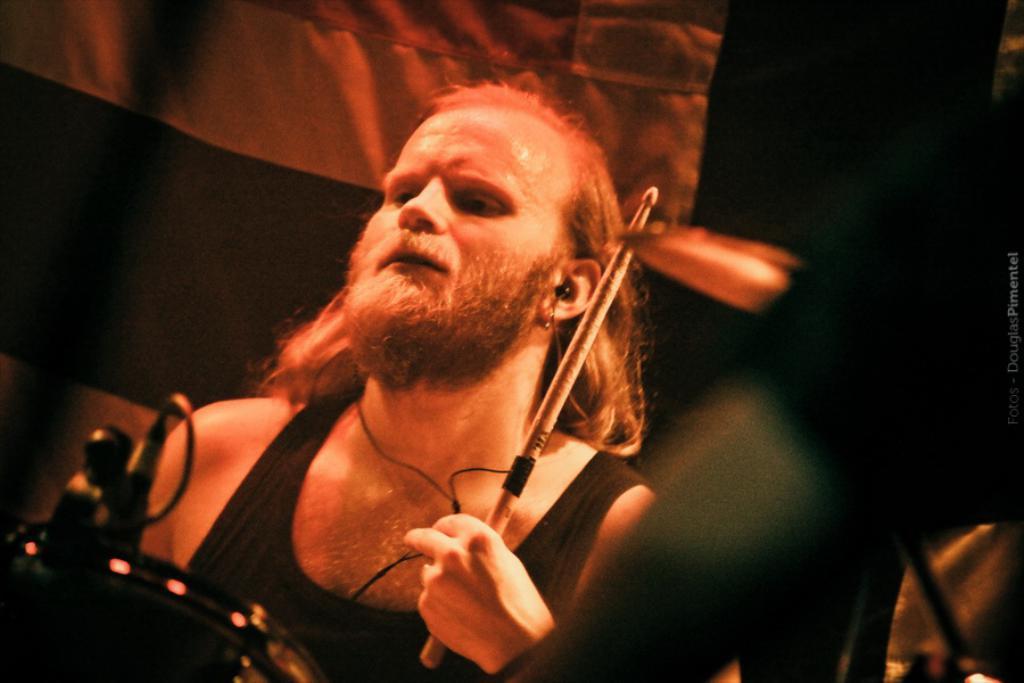How would you summarize this image in a sentence or two? In this picture we can see a man holding a stick with his hand, earphones, white banner, some objects and in the background it is dark. 